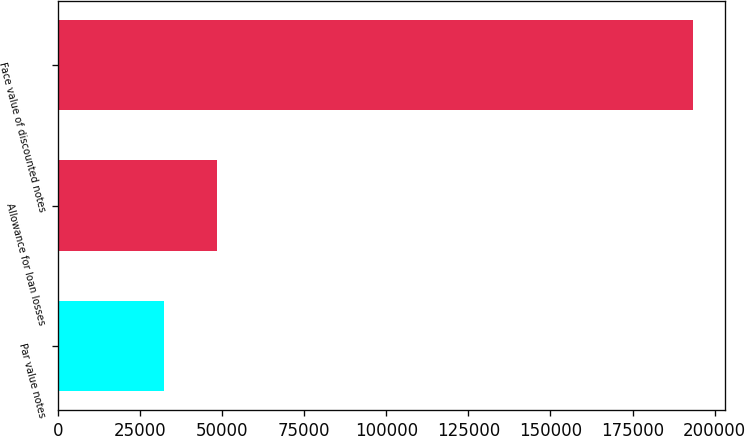<chart> <loc_0><loc_0><loc_500><loc_500><bar_chart><fcel>Par value notes<fcel>Allowance for loan losses<fcel>Face value of discounted notes<nl><fcel>32215<fcel>48349.2<fcel>193557<nl></chart> 